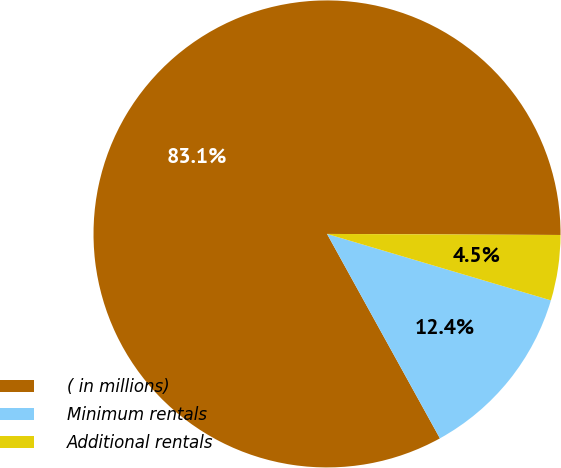Convert chart. <chart><loc_0><loc_0><loc_500><loc_500><pie_chart><fcel>( in millions)<fcel>Minimum rentals<fcel>Additional rentals<nl><fcel>83.11%<fcel>12.38%<fcel>4.52%<nl></chart> 